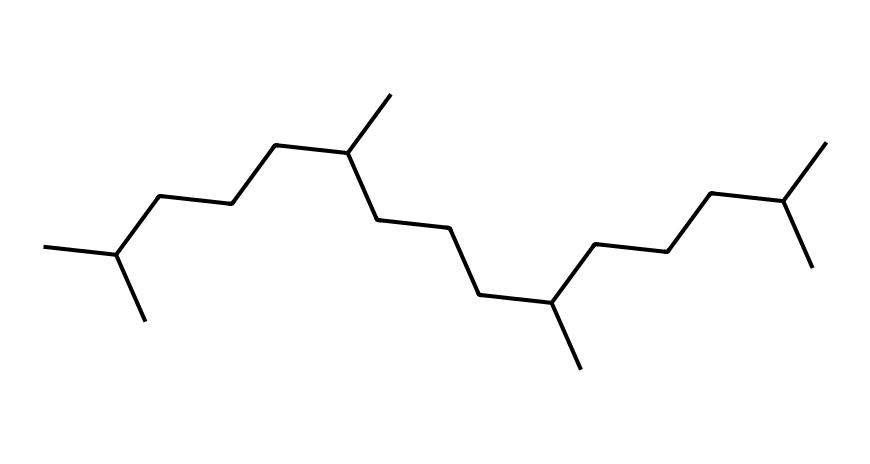What type of hydrocarbon is depicted in this chemical? The chemical structure represents an alkane because it consists solely of carbon and hydrogen atoms, with single bonds connecting carbon atoms (not showing any double or triple bonds).
Answer: alkane How many carbon atoms are in this structure? By counting all the carbon atoms in the provided SMILES, there are 30 carbon atoms present in the chemical structure.
Answer: 30 What is the degree of branching in this hydrocarbon? The presence of multiple branched chains indicates high branching; in the structure, many C groups are present off the main chain, which is typical for branched alkanes.
Answer: high What is the general use of this chemical? This chemical is commonly used as a lubricant, particularly in specialized applications like telescope mechanisms, providing a smooth and stable operating environment.
Answer: lubricant What is the expected viscosity of this synthetic oil? Based on the structure, which has a significant number of carbon atoms and branching, the expected viscosity would be relatively high due to the large molecular weight and complex structure.
Answer: high Does this lubricant contain any functional groups? The structure presented is of an alkane and does not show any functional groups such as hydroxyl, carbonyl, or carboxyl, which would be indicated by other structural features.
Answer: no How does the branching affect the properties of this lubricant? The branching generally lowers the boiling point of hydrocarbons and improves fluidity, making this lubricant more effective in maintaining a stable operation over a range of temperatures.
Answer: improves fluidity 